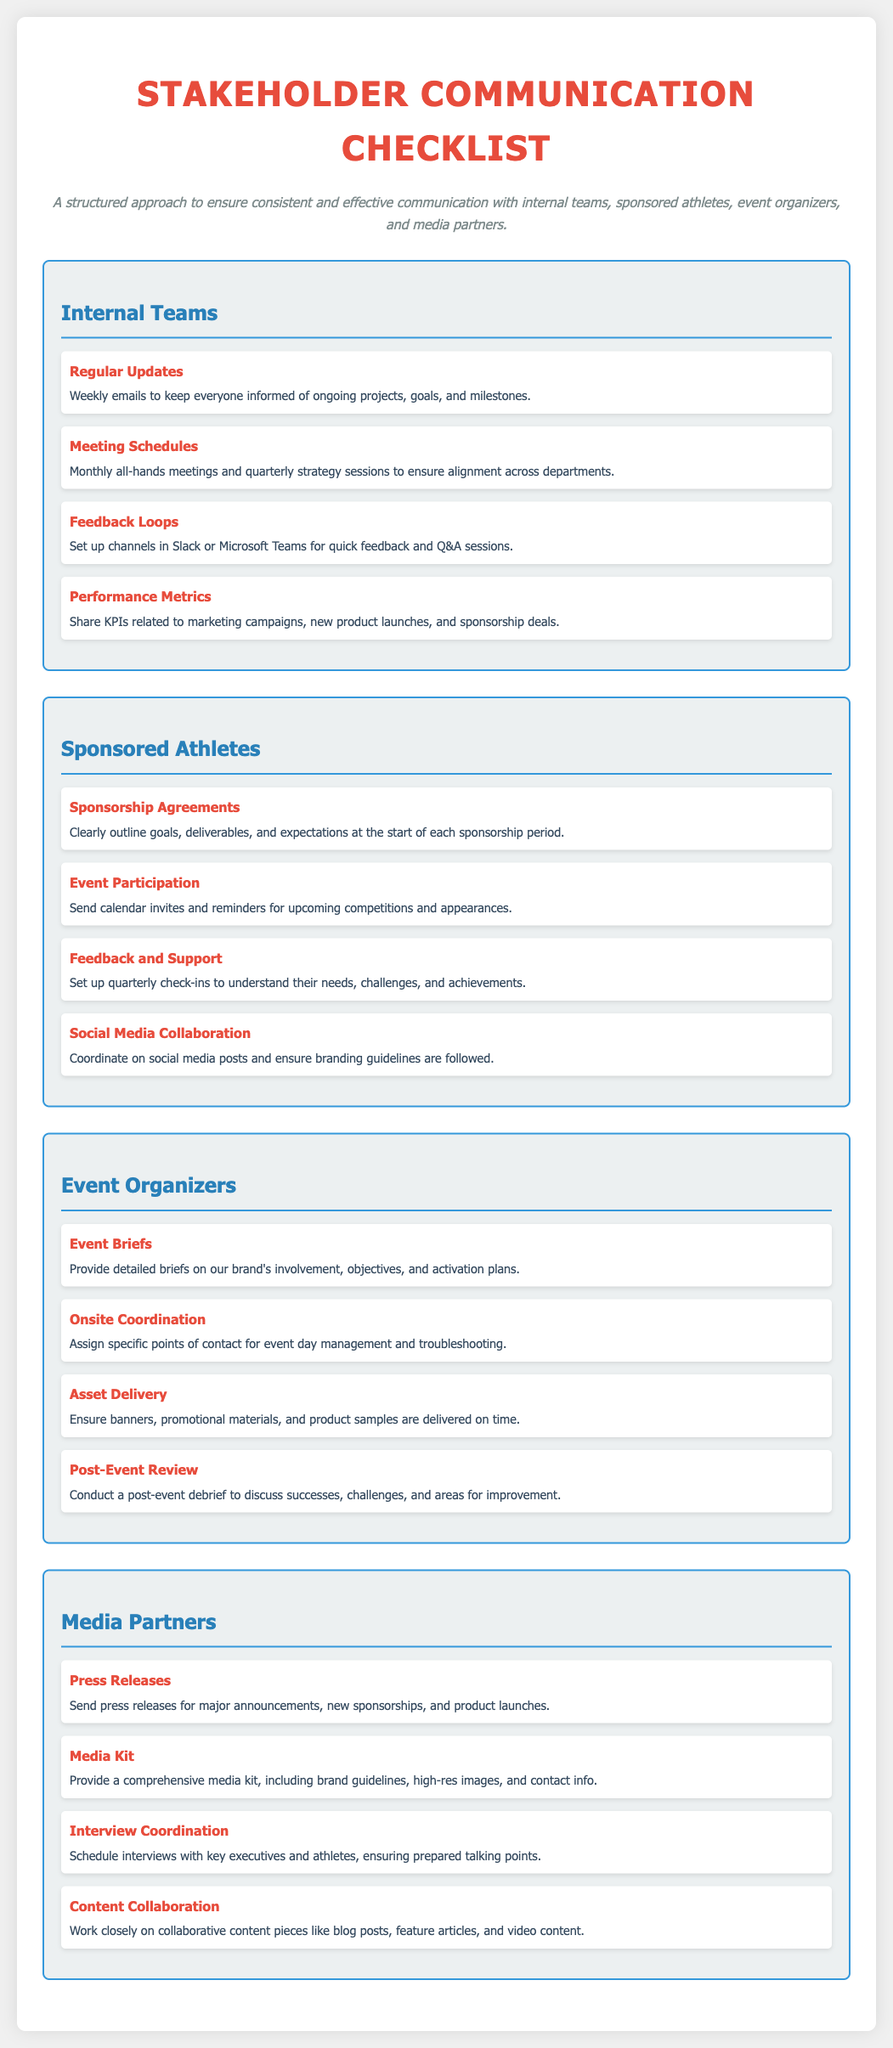What is the title of the document? The title can be found at the top of the checklist and indicates the purpose of the content.
Answer: Stakeholder Communication Checklist How many sections are there in the document? The number of sections is indicated by the distinct parts of the checklist focusing on different stakeholders.
Answer: Four What color represents the section titles? The color used in the section titles is specified within the styling of the document.
Answer: Blue How often should internal teams receive updates? The frequency for updates is detailed in the Internal Teams section under Regular Updates.
Answer: Weekly What is one item related to sponsored athletes? Each section includes multiple checklist items and one can be directly specified from the Sponsored Athletes section.
Answer: Sponsorship Agreements What do press releases inform about? The item within Media Partners outlines what press releases should cover.
Answer: Major announcements What is the purpose of the post-event review? The purpose is explained in the Event Organizers section.
Answer: To discuss successes, challenges, and areas for improvement How frequently should check-ins occur with sponsored athletes? This detail is specifically mentioned in the Sponsored Athletes section regarding engagement.
Answer: Quarterly What type of collaboration is mentioned for media partners? This type of collaboration indicates how they work together on content.
Answer: Content Collaboration 